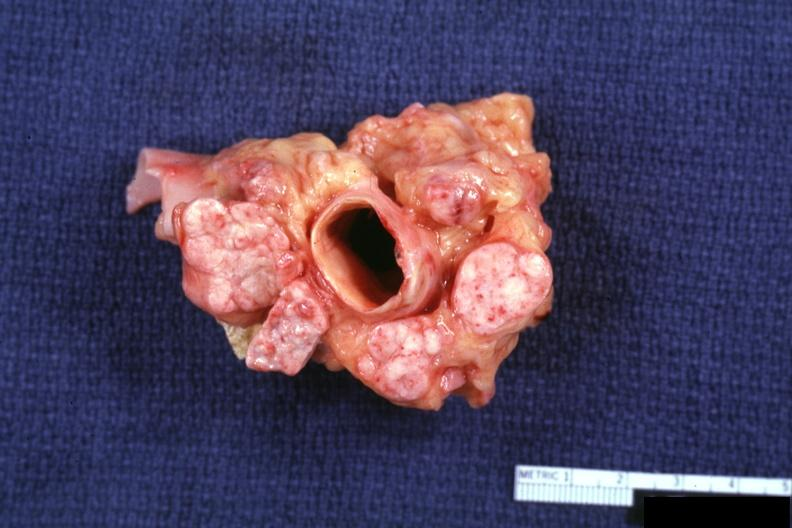does this image show excellent cross section of aorta and nodes with obvious tumor in enlarged nodes?
Answer the question using a single word or phrase. Yes 